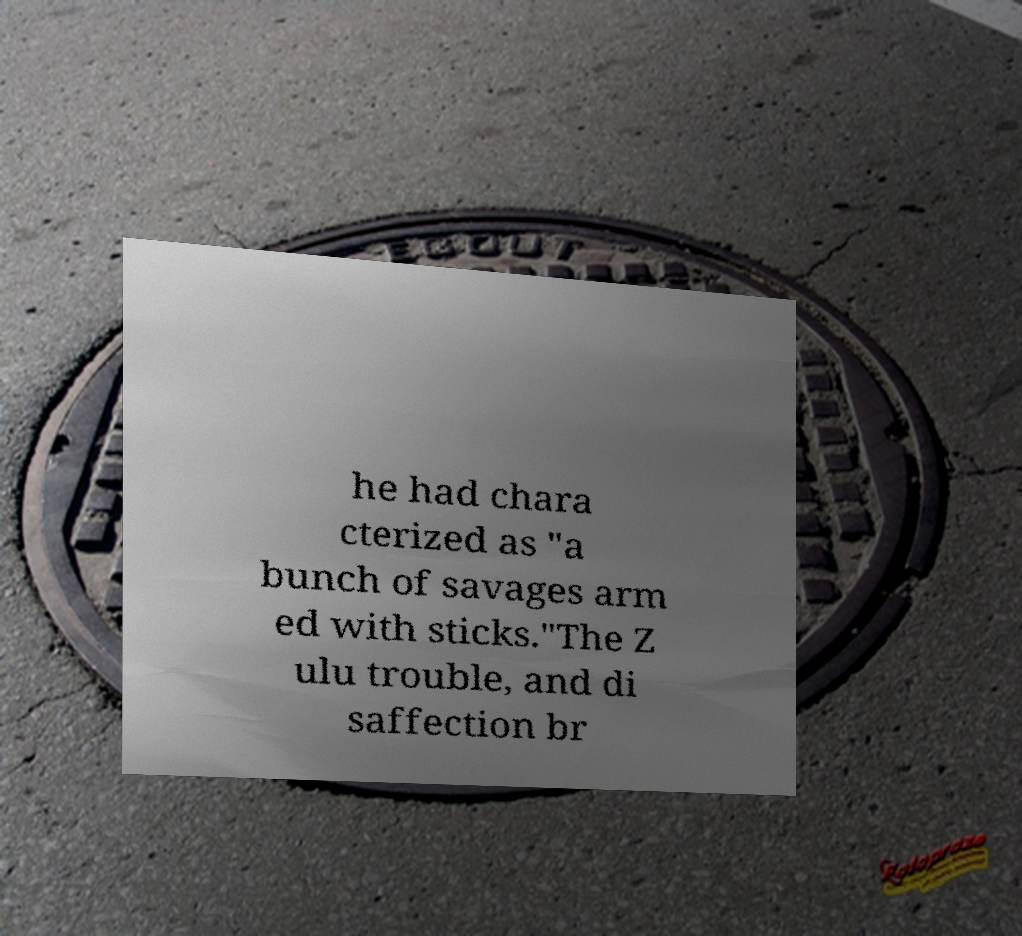What messages or text are displayed in this image? I need them in a readable, typed format. he had chara cterized as "a bunch of savages arm ed with sticks."The Z ulu trouble, and di saffection br 